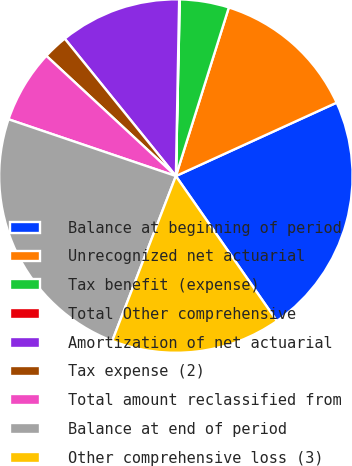Convert chart. <chart><loc_0><loc_0><loc_500><loc_500><pie_chart><fcel>Balance at beginning of period<fcel>Unrecognized net actuarial<fcel>Tax benefit (expense)<fcel>Total Other comprehensive<fcel>Amortization of net actuarial<fcel>Tax expense (2)<fcel>Total amount reclassified from<fcel>Balance at end of period<fcel>Other comprehensive loss (3)<nl><fcel>22.13%<fcel>13.34%<fcel>4.49%<fcel>0.06%<fcel>11.12%<fcel>2.27%<fcel>6.7%<fcel>24.34%<fcel>15.55%<nl></chart> 